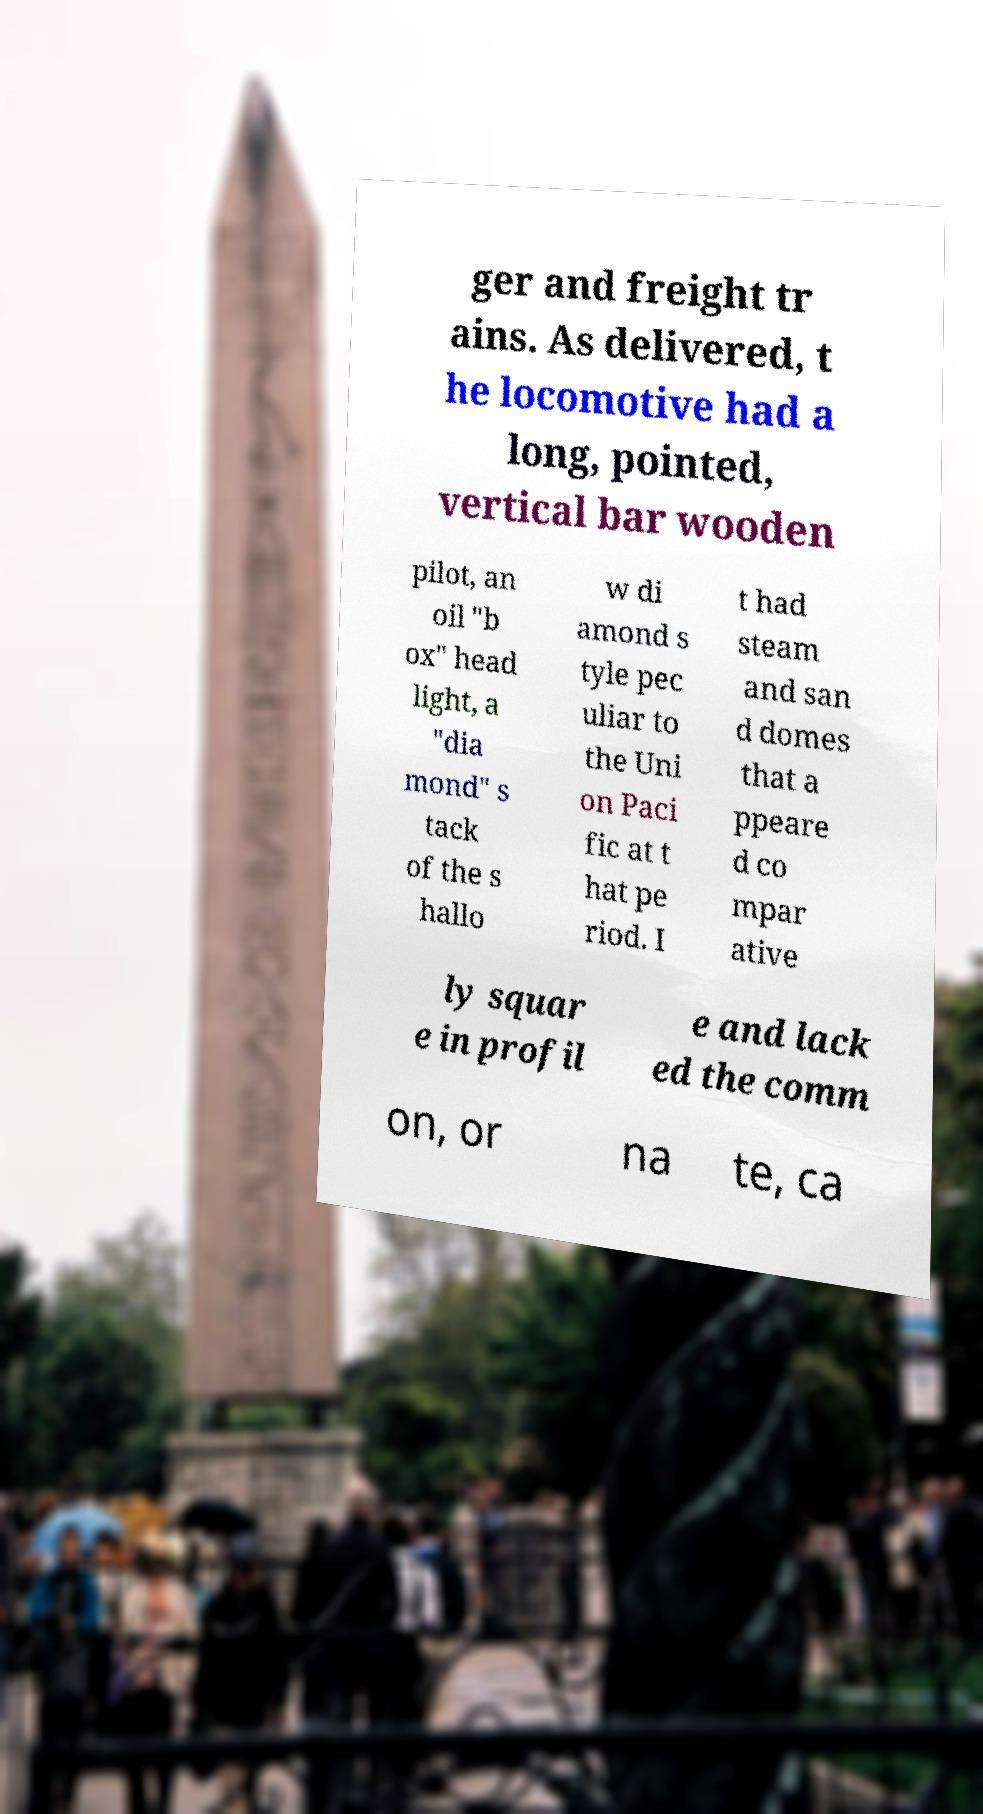For documentation purposes, I need the text within this image transcribed. Could you provide that? ger and freight tr ains. As delivered, t he locomotive had a long, pointed, vertical bar wooden pilot, an oil "b ox" head light, a "dia mond" s tack of the s hallo w di amond s tyle pec uliar to the Uni on Paci fic at t hat pe riod. I t had steam and san d domes that a ppeare d co mpar ative ly squar e in profil e and lack ed the comm on, or na te, ca 